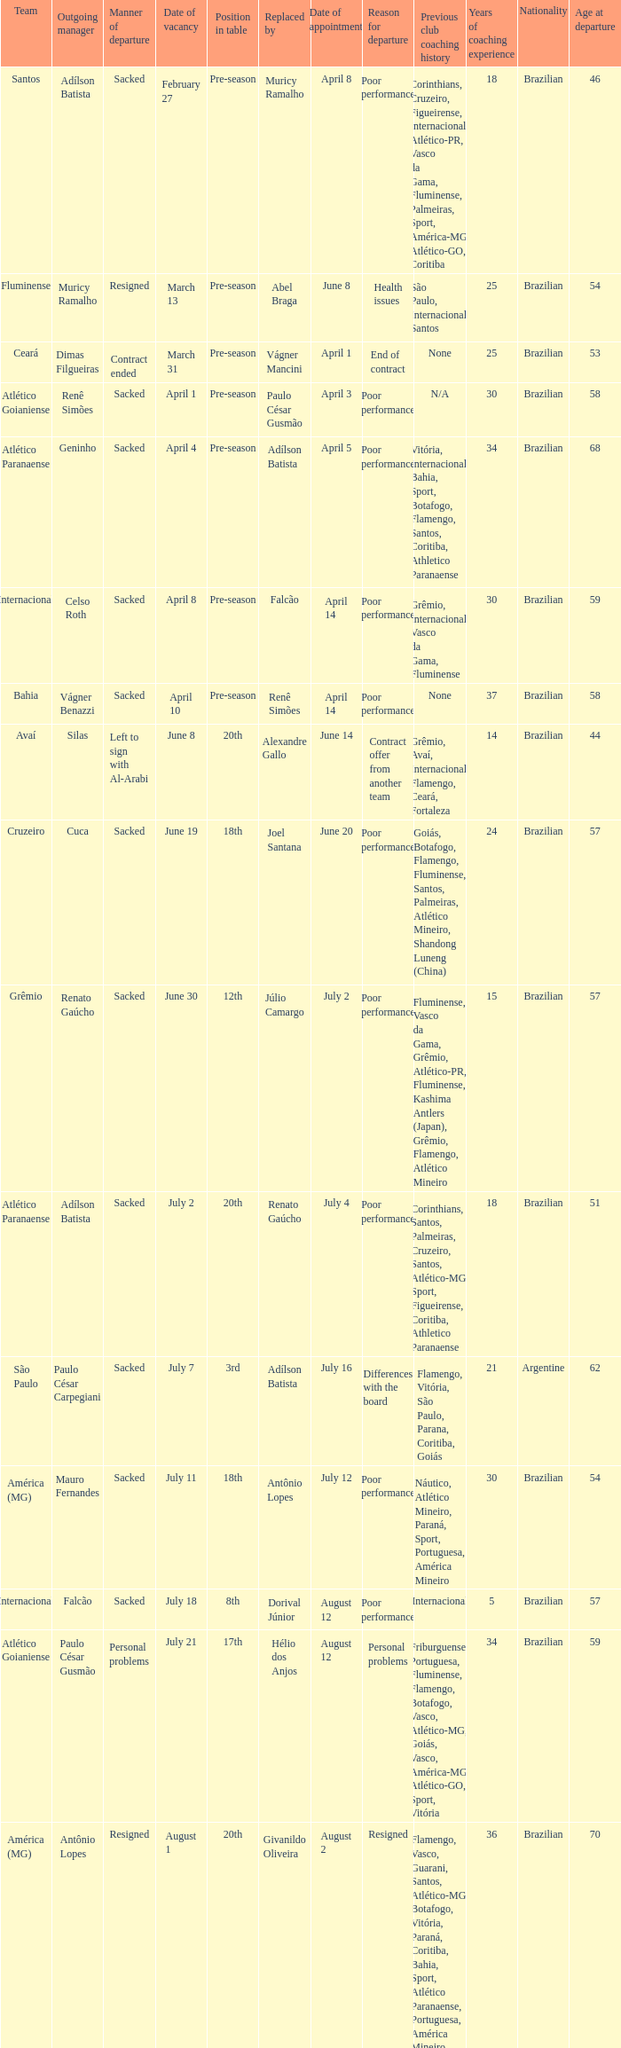Who was replaced as manager on June 20? Cuca. 